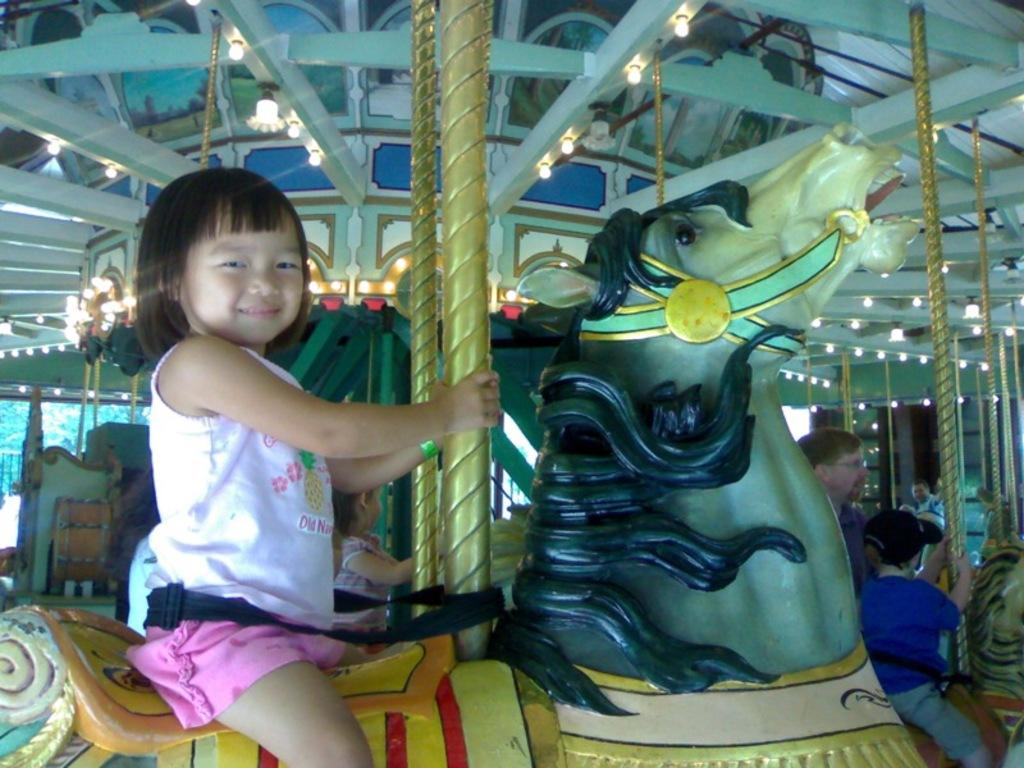Who is present in the image? There are children in the image. What are the children doing in the image? The children are riding a carousel. What shape is the zephyr in the image? There is no mention of a zephyr in the image, so we cannot determine its shape. 